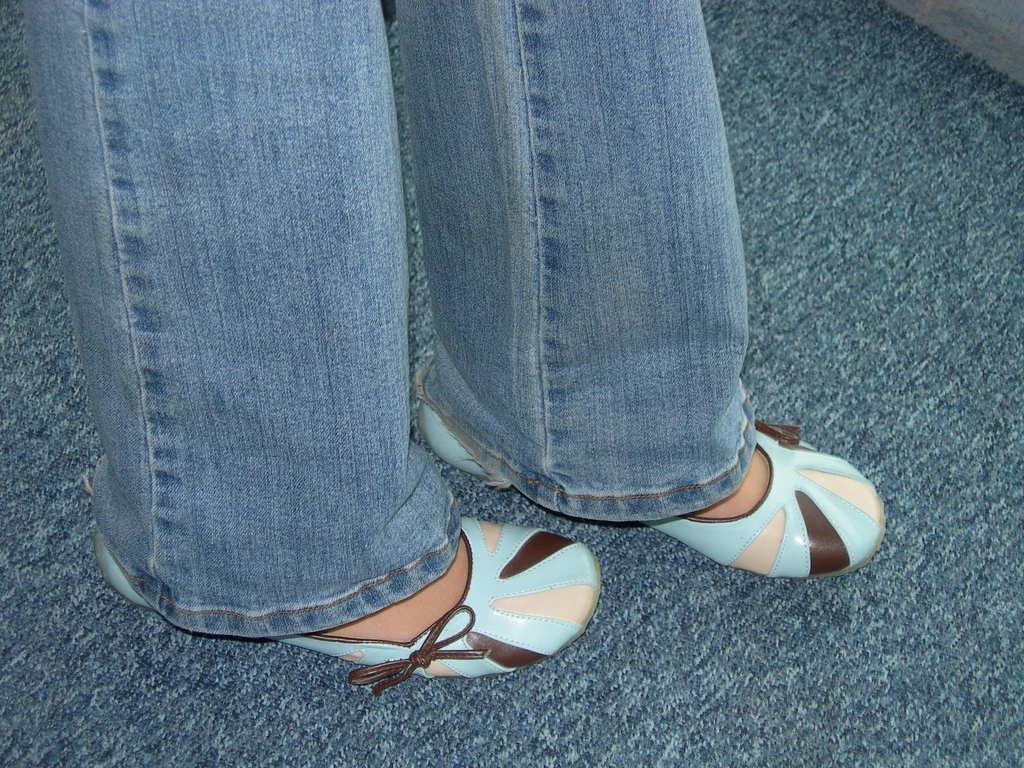Can you describe this image briefly? In this image we can see the legs of a person on the floor. 